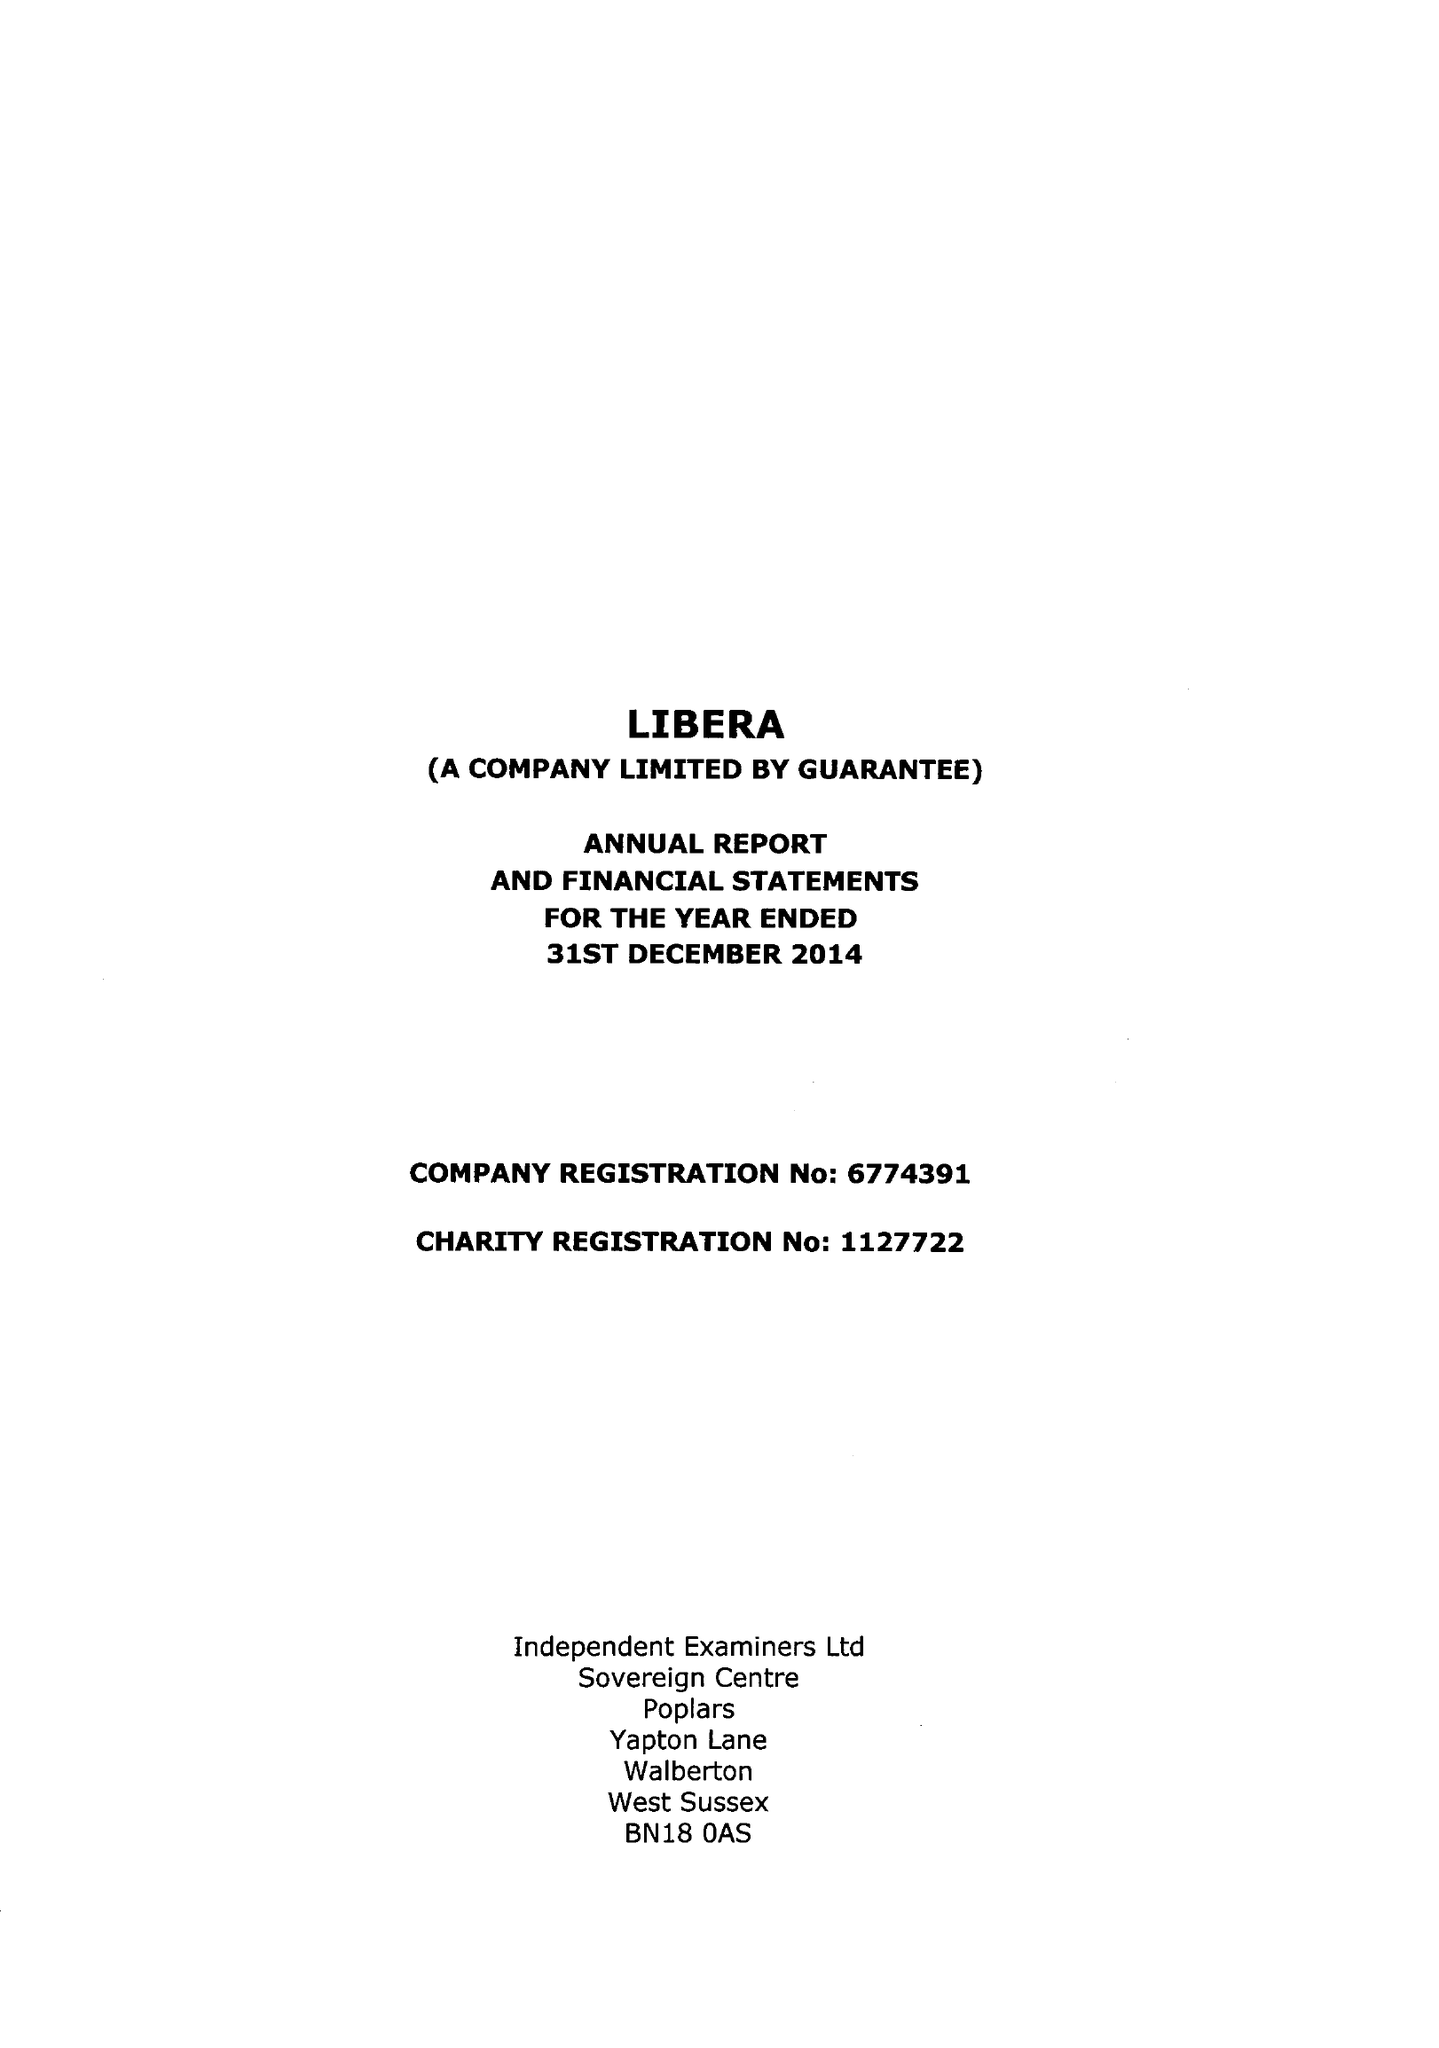What is the value for the address__street_line?
Answer the question using a single word or phrase. 20 LIME TREE GROVE 